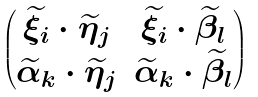Convert formula to latex. <formula><loc_0><loc_0><loc_500><loc_500>\begin{pmatrix} \widetilde { \xi } _ { i } \cdot \widetilde { \eta } _ { j } & \widetilde { \xi } _ { i } \cdot \widetilde { \beta } _ { l } \\ \widetilde { \alpha } _ { k } \cdot \widetilde { \eta } _ { j } & \widetilde { \alpha } _ { k } \cdot \widetilde { \beta } _ { l } \\ \end{pmatrix}</formula> 